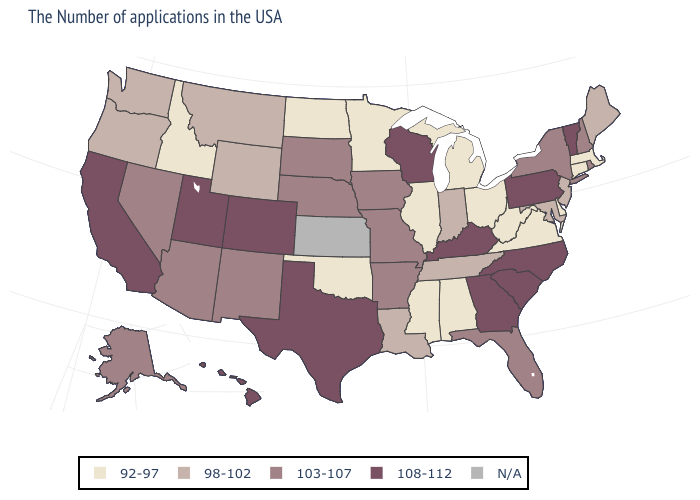What is the highest value in the Northeast ?
Short answer required. 108-112. Which states hav the highest value in the MidWest?
Write a very short answer. Wisconsin. Does North Carolina have the highest value in the USA?
Write a very short answer. Yes. Name the states that have a value in the range 103-107?
Keep it brief. Rhode Island, New Hampshire, New York, Florida, Missouri, Arkansas, Iowa, Nebraska, South Dakota, New Mexico, Arizona, Nevada, Alaska. What is the highest value in states that border Texas?
Write a very short answer. 103-107. What is the value of California?
Write a very short answer. 108-112. Does the first symbol in the legend represent the smallest category?
Give a very brief answer. Yes. Among the states that border Alabama , does Florida have the highest value?
Keep it brief. No. Name the states that have a value in the range 98-102?
Short answer required. Maine, New Jersey, Maryland, Indiana, Tennessee, Louisiana, Wyoming, Montana, Washington, Oregon. What is the value of Arkansas?
Concise answer only. 103-107. What is the highest value in states that border Wyoming?
Keep it brief. 108-112. What is the value of North Carolina?
Short answer required. 108-112. Among the states that border Virginia , which have the highest value?
Short answer required. North Carolina, Kentucky. 